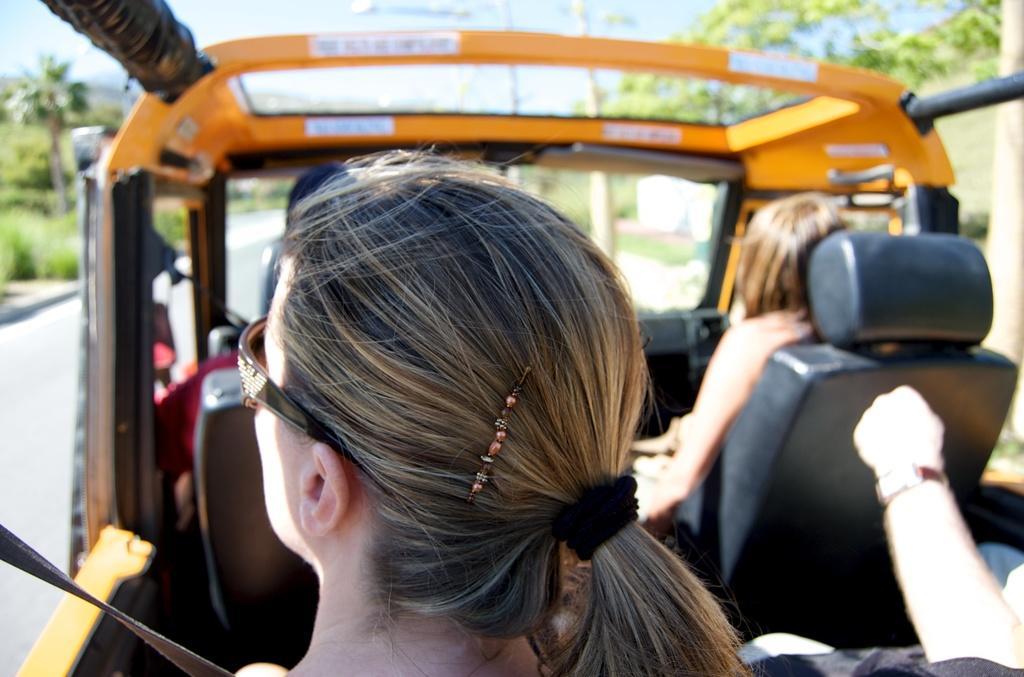Could you give a brief overview of what you see in this image? In the center of the image we can see people travelling in a vehicle. In the background of the image there are trees, sky. To the left side of the image there is road. 